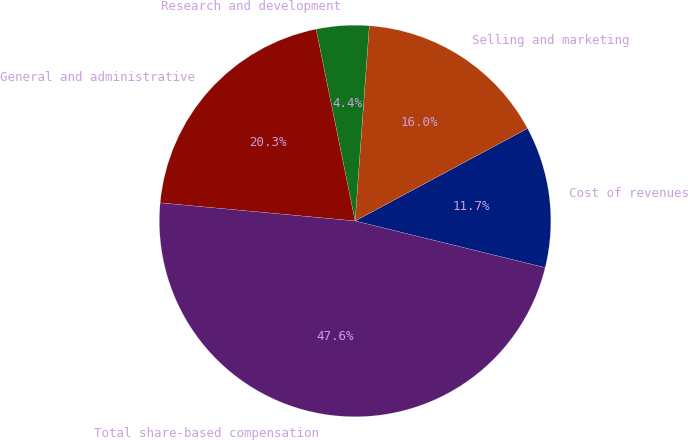Convert chart. <chart><loc_0><loc_0><loc_500><loc_500><pie_chart><fcel>Cost of revenues<fcel>Selling and marketing<fcel>Research and development<fcel>General and administrative<fcel>Total share-based compensation<nl><fcel>11.67%<fcel>16.0%<fcel>4.35%<fcel>20.33%<fcel>47.64%<nl></chart> 